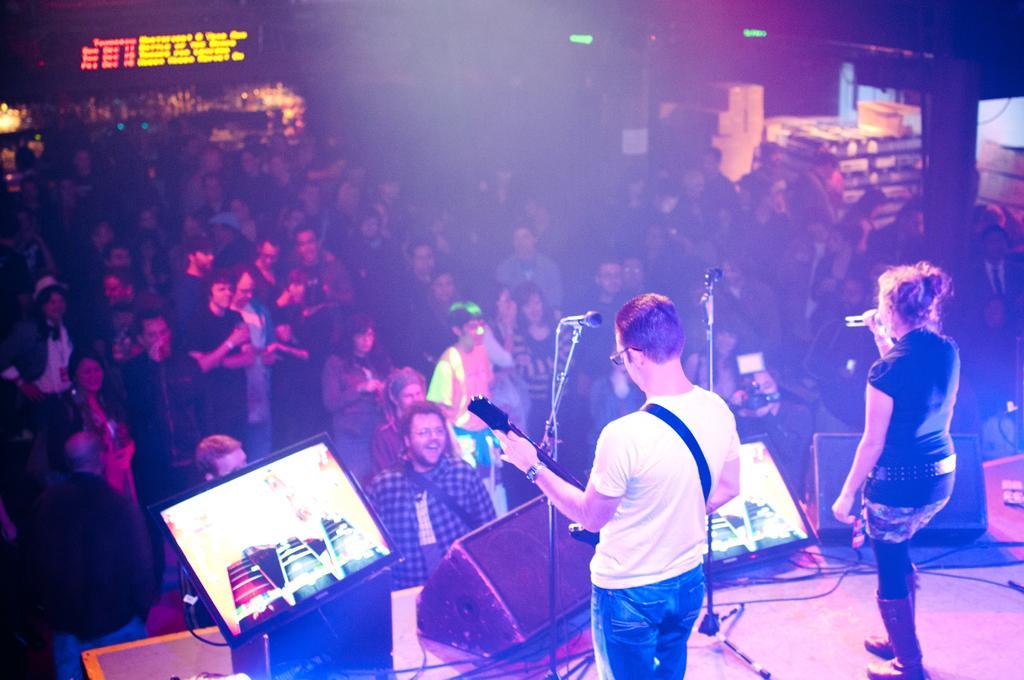Describe this image in one or two sentences. In this image, we can see some people standing and there is a man and a woman standing on the stage, the man is holding a guitar and the woman is singing in the microphone. 